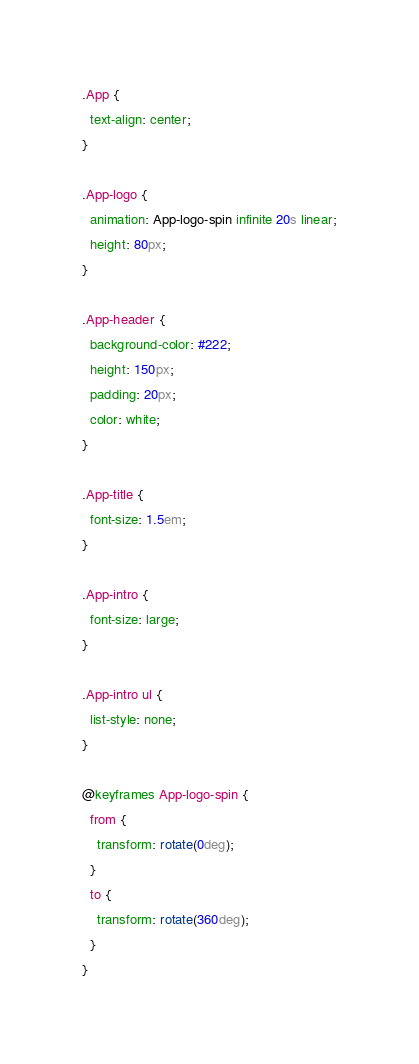Convert code to text. <code><loc_0><loc_0><loc_500><loc_500><_CSS_>.App {
  text-align: center;
}

.App-logo {
  animation: App-logo-spin infinite 20s linear;
  height: 80px;
}

.App-header {
  background-color: #222;
  height: 150px;
  padding: 20px;
  color: white;
}

.App-title {
  font-size: 1.5em;
}

.App-intro {
  font-size: large;
}

.App-intro ul {
  list-style: none;
}

@keyframes App-logo-spin {
  from {
    transform: rotate(0deg);
  }
  to {
    transform: rotate(360deg);
  }
}
</code> 